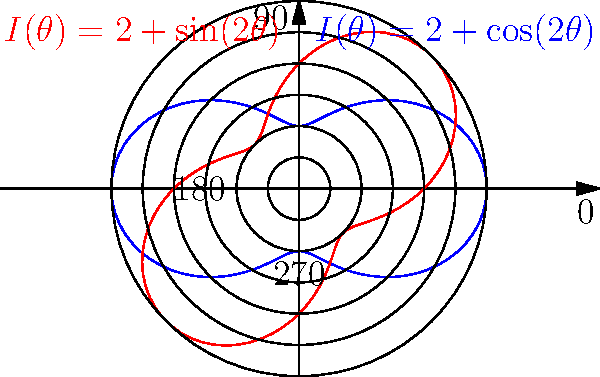The polar rose diagrams shown represent the intensity of solar radiation $I(\theta)$ as a function of the angle $\theta$ for two different photovoltaic systems. The blue curve is described by $I(\theta) = 2 + \cos(2\theta)$, and the red curve by $I(\theta) = 2 + \sin(2\theta)$. What is the total area enclosed by both curves, assuming the radial units are in $\text{kW}/\text{m}^2$? To find the total area enclosed by both curves, we need to:

1) Calculate the area of each individual curve.
2) Add these areas together.

For a polar curve $r = f(\theta)$, the area is given by:

$$A = \frac{1}{2} \int_0^{2\pi} [f(\theta)]^2 d\theta$$

For the blue curve: $I(\theta) = 2 + \cos(2\theta)$
$$A_1 = \frac{1}{2} \int_0^{2\pi} [2 + \cos(2\theta)]^2 d\theta$$
$$= \frac{1}{2} \int_0^{2\pi} [4 + 4\cos(2\theta) + \cos^2(2\theta)] d\theta$$
$$= \frac{1}{2} [4\theta + 2\sin(2\theta) + \frac{1}{2}\theta + \frac{1}{4}\sin(4\theta)]_0^{2\pi}$$
$$= \frac{1}{2} [8\pi + \frac{1}{2}(2\pi)] = 4\pi + \frac{\pi}{2} = \frac{9\pi}{2}$$

For the red curve: $I(\theta) = 2 + \sin(2\theta)$
The calculation is identical due to the symmetry of sine and cosine functions.
$$A_2 = \frac{9\pi}{2}$$

Total area:
$$A_{total} = A_1 + A_2 = \frac{9\pi}{2} + \frac{9\pi}{2} = 9\pi \text{ kW}^2/\text{m}^4$$
Answer: $9\pi \text{ kW}^2/\text{m}^4$ 